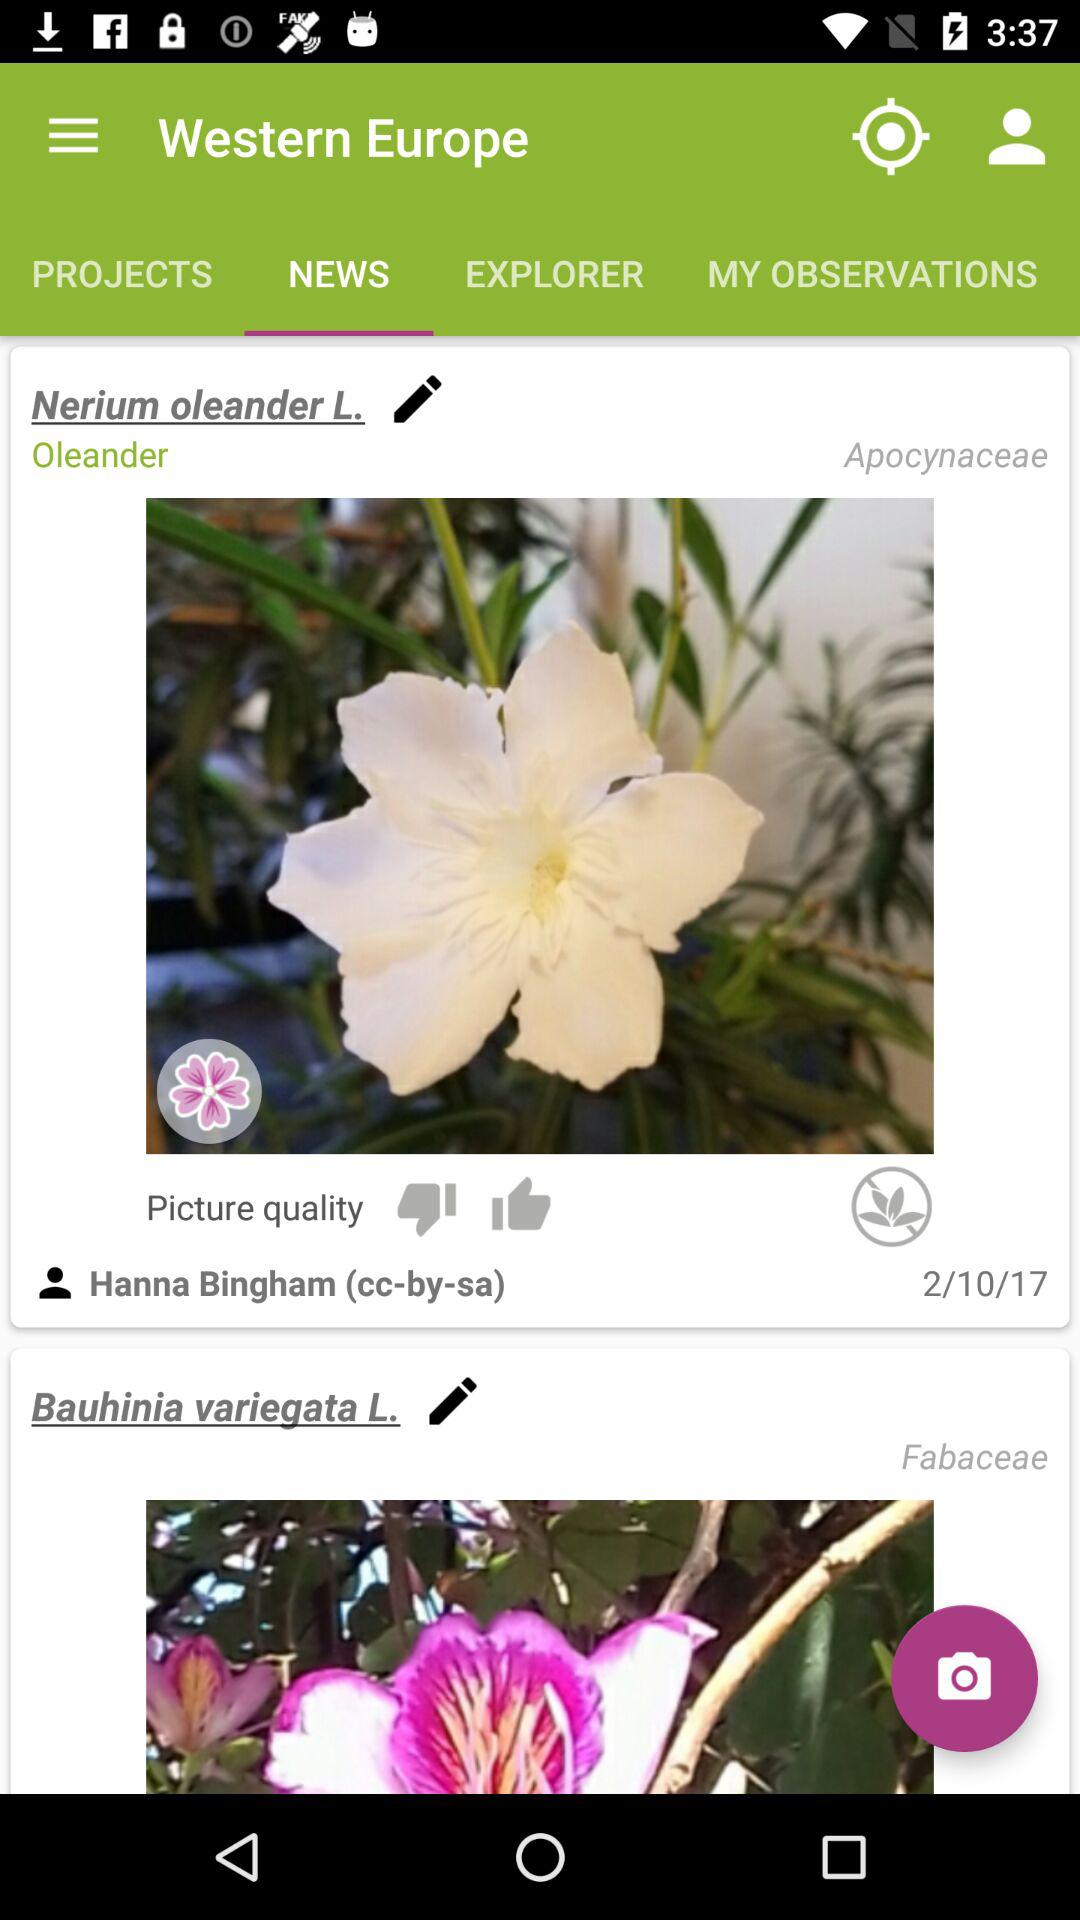Who posted the post? The post was posted by Hanna Bingham. 